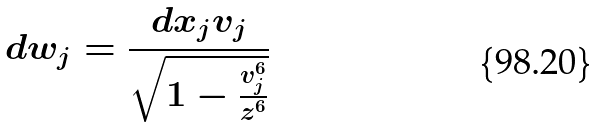Convert formula to latex. <formula><loc_0><loc_0><loc_500><loc_500>d w _ { j } = \frac { d x _ { j } v _ { j } } { \sqrt { 1 - \frac { v _ { j } ^ { 6 } } { z ^ { 6 } } } }</formula> 